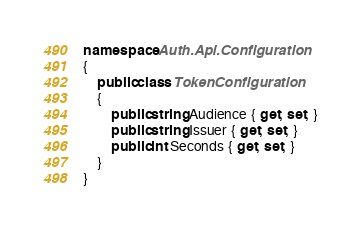Convert code to text. <code><loc_0><loc_0><loc_500><loc_500><_C#_>namespace Auth.Api.Configuration
{
    public class TokenConfiguration
    {
        public string Audience { get; set; }
        public string Issuer { get; set; }
        public int Seconds { get; set; }
    }
}</code> 